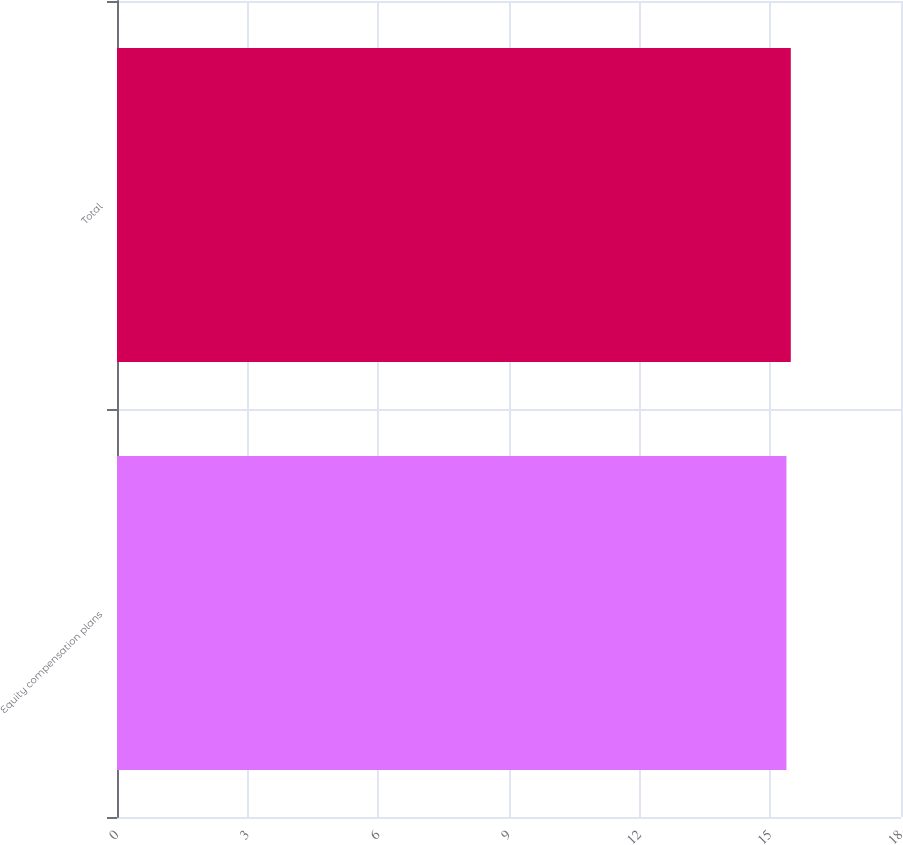<chart> <loc_0><loc_0><loc_500><loc_500><bar_chart><fcel>Equity compensation plans<fcel>Total<nl><fcel>15.37<fcel>15.47<nl></chart> 